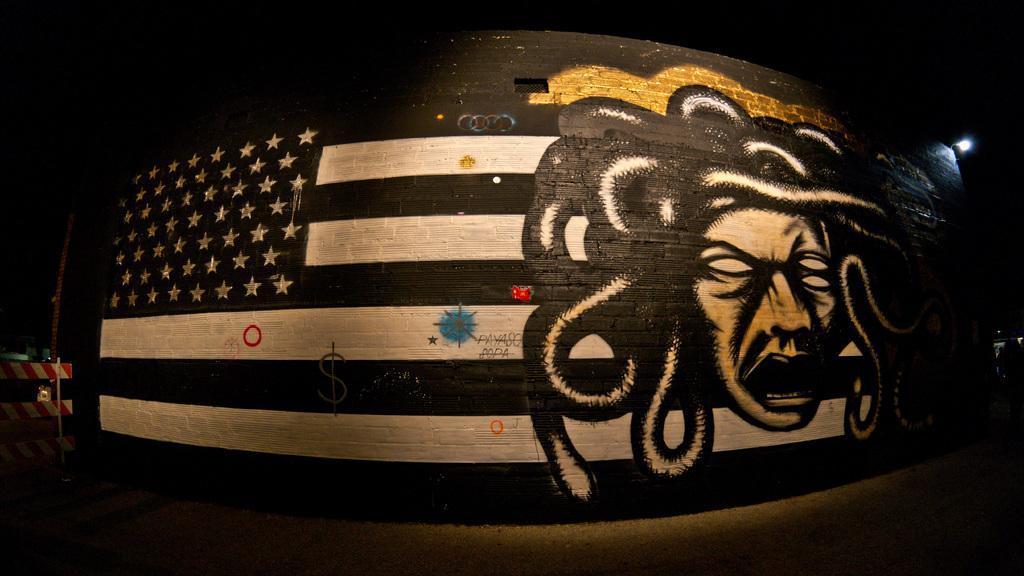In one or two sentences, can you explain what this image depicts? In the image we can see there is a wall painted and there is a cartoon face of a person on the wall. There is a painting of USA flag and the painting is done with black and white colours. Background of the image is dark. 